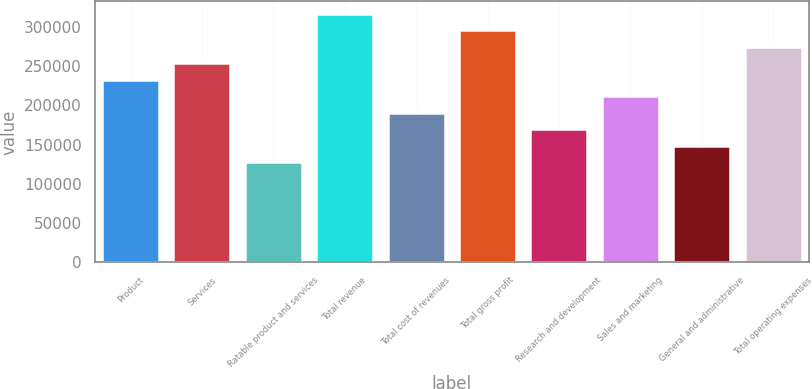Convert chart to OTSL. <chart><loc_0><loc_0><loc_500><loc_500><bar_chart><fcel>Product<fcel>Services<fcel>Ratable product and services<fcel>Total revenue<fcel>Total cost of revenues<fcel>Total gross profit<fcel>Research and development<fcel>Sales and marketing<fcel>General and administrative<fcel>Total operating expenses<nl><fcel>232799<fcel>253807<fcel>127759<fcel>316832<fcel>190783<fcel>295823<fcel>169775<fcel>211791<fcel>148767<fcel>274815<nl></chart> 